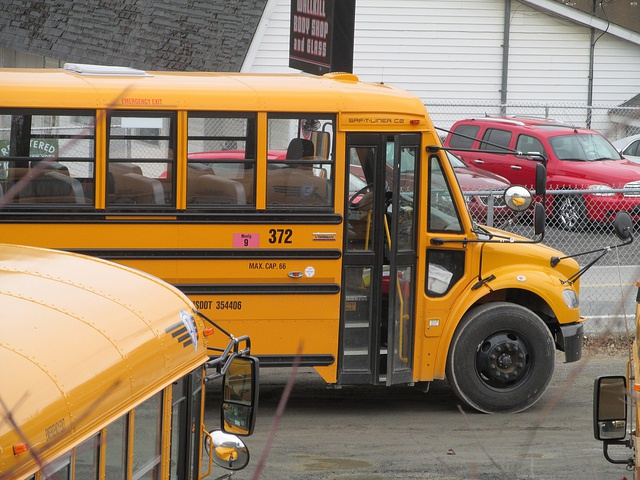Describe the objects in this image and their specific colors. I can see bus in gray, black, orange, and darkgray tones, bus in gray, tan, ivory, and orange tones, car in gray, salmon, darkgray, and brown tones, car in gray, darkgray, and brown tones, and car in gray, lightgray, and darkgray tones in this image. 